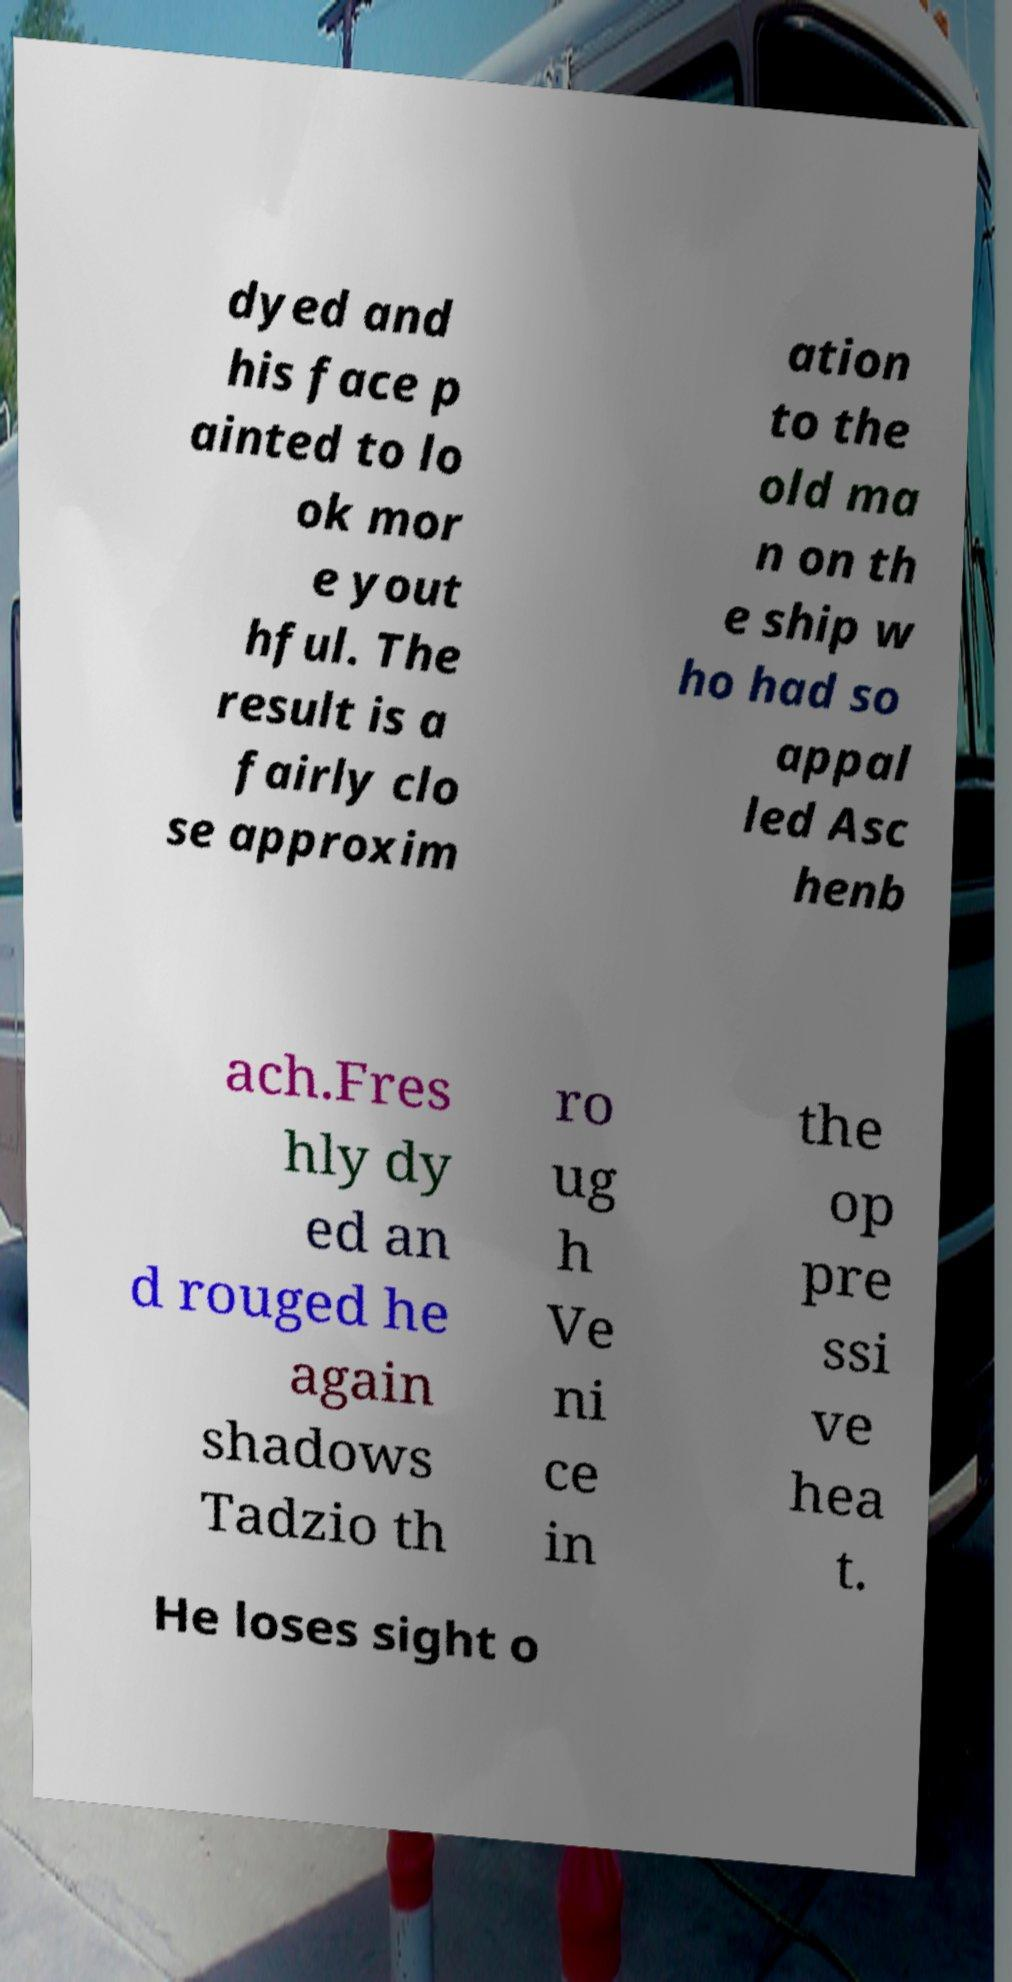There's text embedded in this image that I need extracted. Can you transcribe it verbatim? dyed and his face p ainted to lo ok mor e yout hful. The result is a fairly clo se approxim ation to the old ma n on th e ship w ho had so appal led Asc henb ach.Fres hly dy ed an d rouged he again shadows Tadzio th ro ug h Ve ni ce in the op pre ssi ve hea t. He loses sight o 